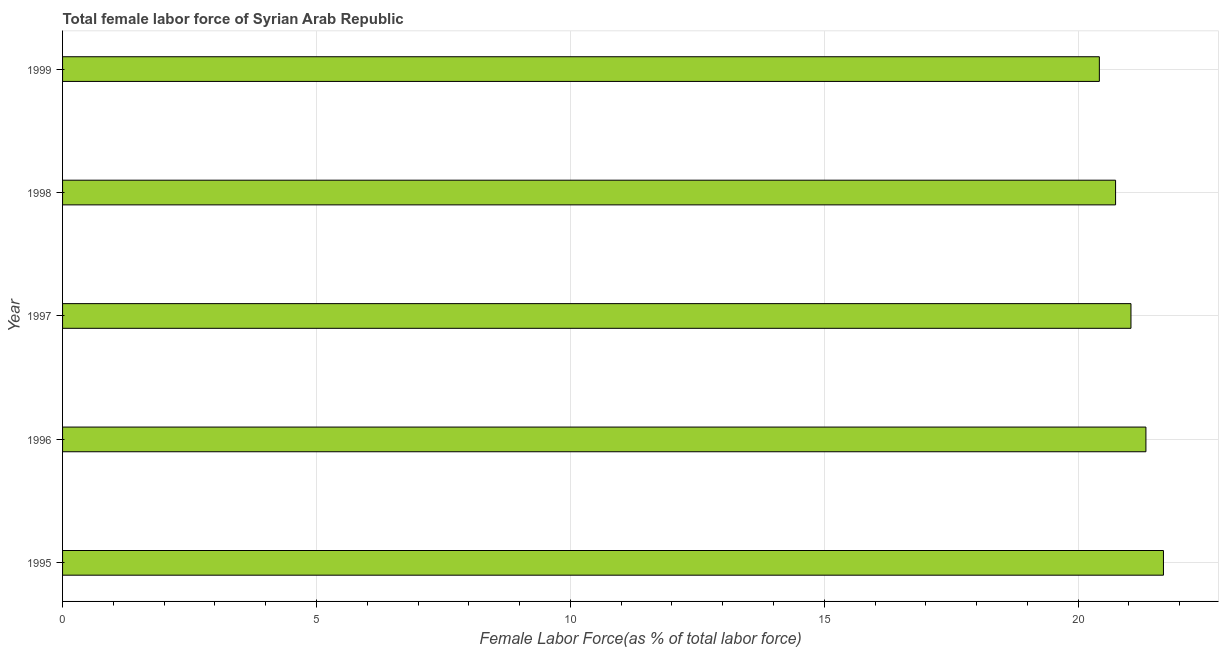Does the graph contain grids?
Your response must be concise. Yes. What is the title of the graph?
Keep it short and to the point. Total female labor force of Syrian Arab Republic. What is the label or title of the X-axis?
Offer a terse response. Female Labor Force(as % of total labor force). What is the total female labor force in 1997?
Make the answer very short. 21.04. Across all years, what is the maximum total female labor force?
Provide a succinct answer. 21.68. Across all years, what is the minimum total female labor force?
Your response must be concise. 20.42. What is the sum of the total female labor force?
Your response must be concise. 105.2. What is the difference between the total female labor force in 1997 and 1998?
Make the answer very short. 0.3. What is the average total female labor force per year?
Your response must be concise. 21.04. What is the median total female labor force?
Ensure brevity in your answer.  21.04. In how many years, is the total female labor force greater than 11 %?
Provide a short and direct response. 5. What is the ratio of the total female labor force in 1997 to that in 1999?
Your response must be concise. 1.03. Is the total female labor force in 1996 less than that in 1998?
Give a very brief answer. No. Is the difference between the total female labor force in 1995 and 1996 greater than the difference between any two years?
Ensure brevity in your answer.  No. What is the difference between the highest and the second highest total female labor force?
Give a very brief answer. 0.34. What is the difference between the highest and the lowest total female labor force?
Your answer should be compact. 1.26. In how many years, is the total female labor force greater than the average total female labor force taken over all years?
Offer a very short reply. 2. How many years are there in the graph?
Keep it short and to the point. 5. What is the Female Labor Force(as % of total labor force) of 1995?
Provide a succinct answer. 21.68. What is the Female Labor Force(as % of total labor force) in 1996?
Keep it short and to the point. 21.33. What is the Female Labor Force(as % of total labor force) of 1997?
Your response must be concise. 21.04. What is the Female Labor Force(as % of total labor force) of 1998?
Your answer should be compact. 20.74. What is the Female Labor Force(as % of total labor force) of 1999?
Offer a terse response. 20.42. What is the difference between the Female Labor Force(as % of total labor force) in 1995 and 1996?
Your answer should be very brief. 0.35. What is the difference between the Female Labor Force(as % of total labor force) in 1995 and 1997?
Ensure brevity in your answer.  0.64. What is the difference between the Female Labor Force(as % of total labor force) in 1995 and 1998?
Provide a succinct answer. 0.94. What is the difference between the Female Labor Force(as % of total labor force) in 1995 and 1999?
Provide a short and direct response. 1.26. What is the difference between the Female Labor Force(as % of total labor force) in 1996 and 1997?
Your answer should be very brief. 0.29. What is the difference between the Female Labor Force(as % of total labor force) in 1996 and 1998?
Keep it short and to the point. 0.6. What is the difference between the Female Labor Force(as % of total labor force) in 1996 and 1999?
Make the answer very short. 0.92. What is the difference between the Female Labor Force(as % of total labor force) in 1997 and 1998?
Offer a terse response. 0.3. What is the difference between the Female Labor Force(as % of total labor force) in 1997 and 1999?
Ensure brevity in your answer.  0.62. What is the difference between the Female Labor Force(as % of total labor force) in 1998 and 1999?
Offer a very short reply. 0.32. What is the ratio of the Female Labor Force(as % of total labor force) in 1995 to that in 1997?
Make the answer very short. 1.03. What is the ratio of the Female Labor Force(as % of total labor force) in 1995 to that in 1998?
Your answer should be compact. 1.04. What is the ratio of the Female Labor Force(as % of total labor force) in 1995 to that in 1999?
Your answer should be very brief. 1.06. What is the ratio of the Female Labor Force(as % of total labor force) in 1996 to that in 1999?
Offer a very short reply. 1.04. What is the ratio of the Female Labor Force(as % of total labor force) in 1997 to that in 1998?
Offer a very short reply. 1.01. What is the ratio of the Female Labor Force(as % of total labor force) in 1997 to that in 1999?
Offer a very short reply. 1.03. What is the ratio of the Female Labor Force(as % of total labor force) in 1998 to that in 1999?
Your response must be concise. 1.02. 